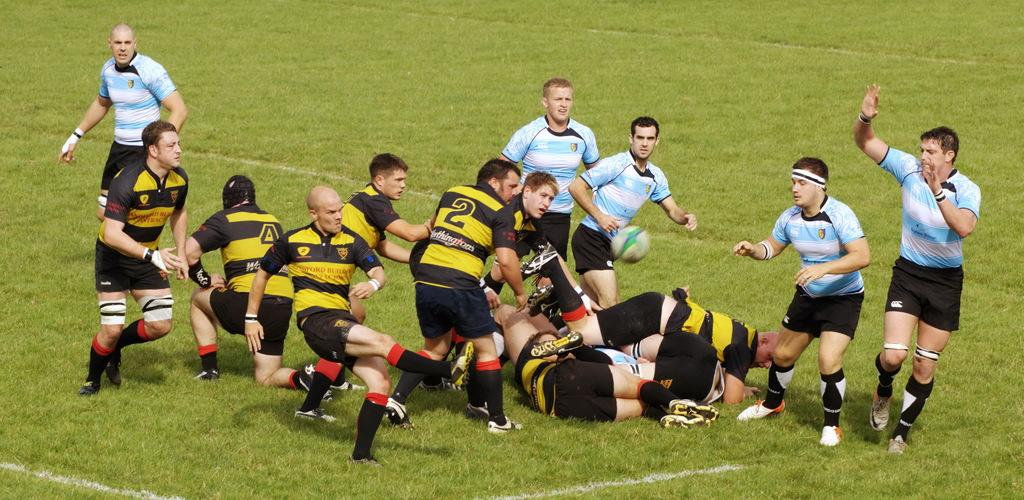What is happening in the center of the image? There are people in the center of the image. Where are the people located? The people are on a grassland. What activity are the people in the center of the image engaged in? The people are about to catch a ball. Are there any other people in the image? Yes, there are people lying on the floor. What is the hope of the person in the image? There is no person in the image expressing hope or any emotions, so it is not possible to determine their hope. 